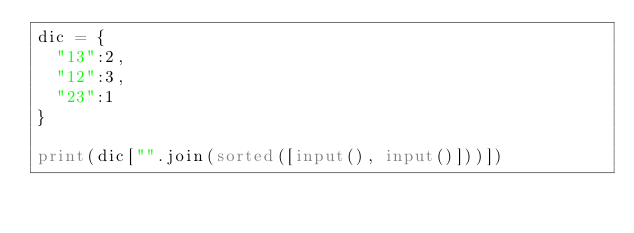<code> <loc_0><loc_0><loc_500><loc_500><_Python_>dic = {
  "13":2,
  "12":3,
  "23":1
}

print(dic["".join(sorted([input(), input()]))])</code> 